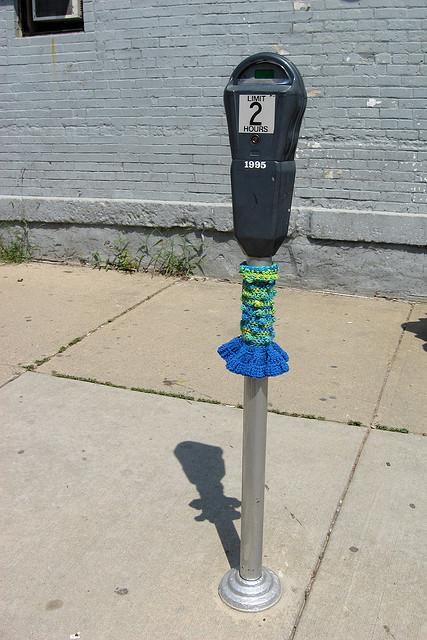Is it at night?
Quick response, please. No. What is growing between the sidewalk?
Answer briefly. Weeds. How many meters are on the pole?
Keep it brief. 1. What is written on the parking meter pole?
Be succinct. 2. What is wrapped around this pole?
Quick response, please. Knitted design. What colors are on the bottom of the parking meter?
Write a very short answer. Silver. How much time is left on the meter?
Give a very brief answer. 2 minutes. 